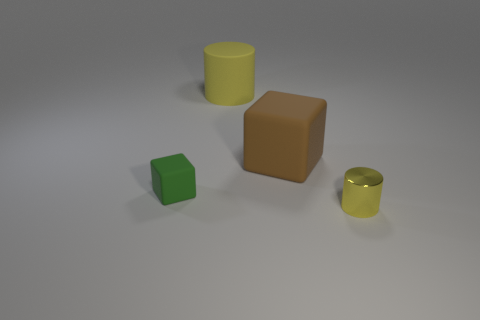Which objects in the image look like they could hold liquid? Of the objects presented, the two cylinders appear capable of holding liquid due to their open tops and hollow shapes. The larger yellow cylinder has more volume, but both could theoretically contain liquids. 